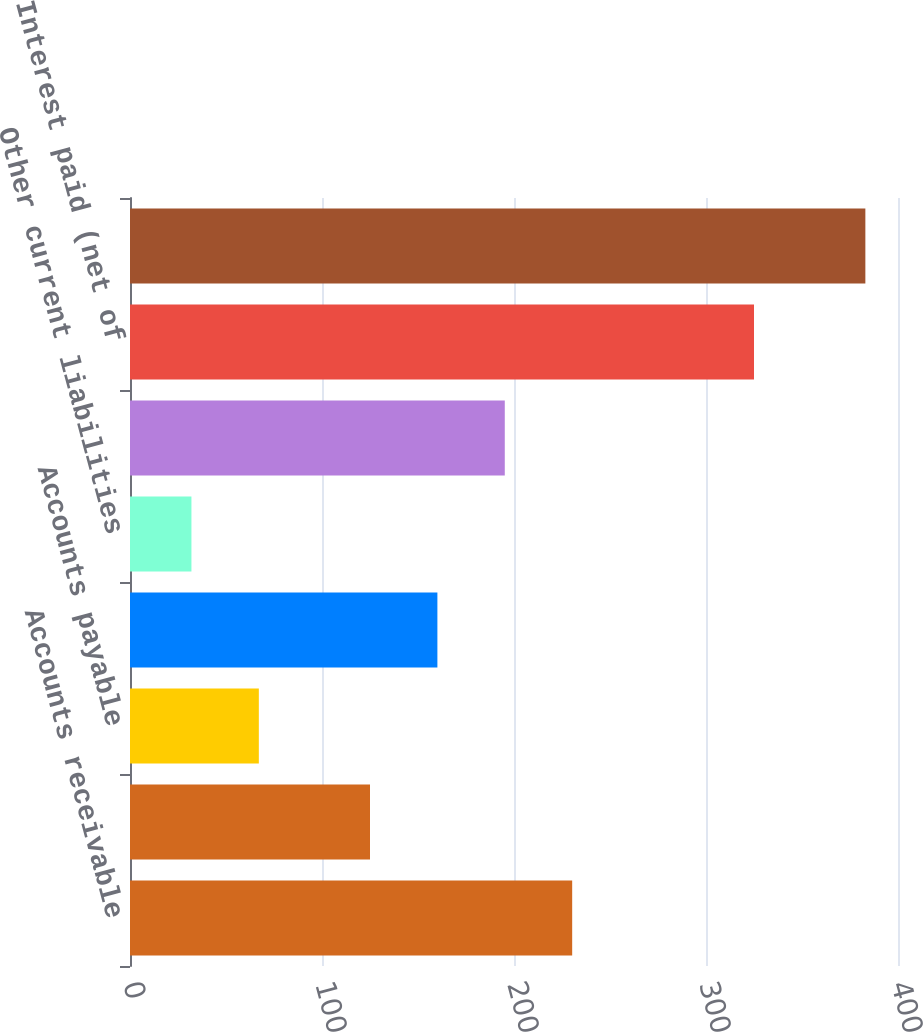Convert chart. <chart><loc_0><loc_0><loc_500><loc_500><bar_chart><fcel>Accounts receivable<fcel>Other current assets<fcel>Accounts payable<fcel>Revenues and royalties payable<fcel>Other current liabilities<fcel>Net change in working capital<fcel>Interest paid (net of<fcel>Income taxes paid (received)<nl><fcel>230.3<fcel>125<fcel>67.1<fcel>160.1<fcel>32<fcel>195.2<fcel>325<fcel>383<nl></chart> 